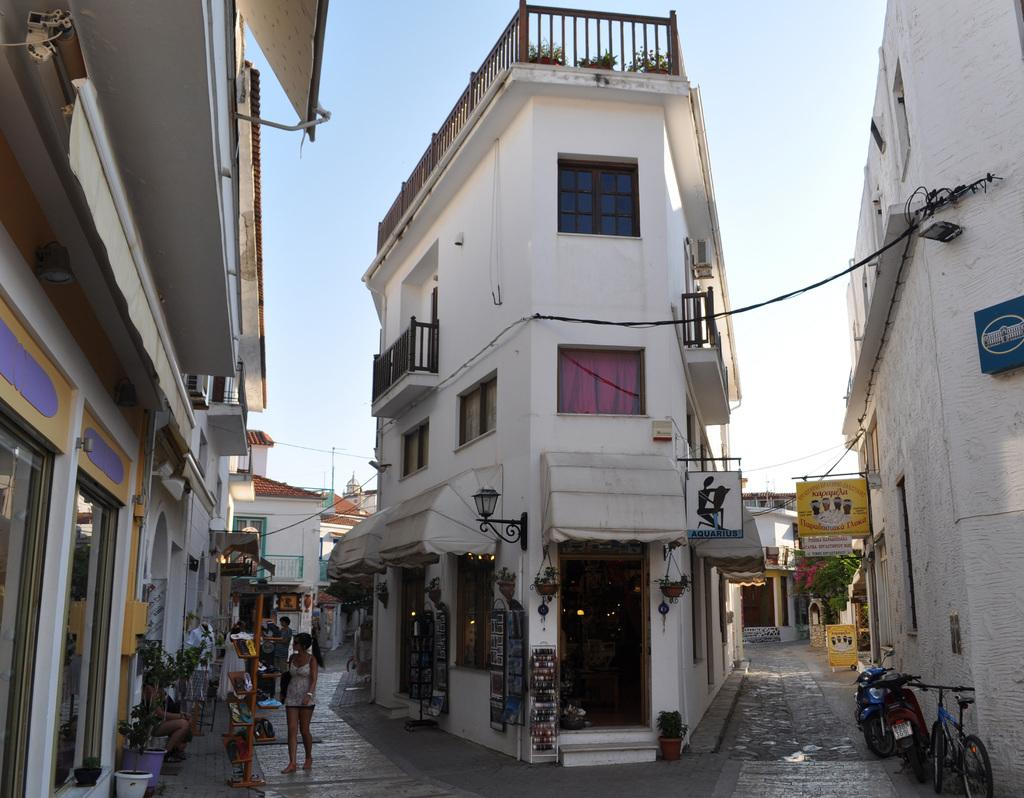How many people are in the group visible in the image? There is a group of people in the image, but the exact number cannot be determined from the provided facts. What type of structures can be seen in the image? There are buildings in the image. What mode of transportation is visible in the image? A bicycle is visible in the image, and motorcycles are present on the road in the image. What can be found in the background of the image? There are notice boards and cables visible in the background of the image. What type of apparel is the lock wearing in the image? There is no lock or apparel present in the image. What type of hall can be seen in the background of the image? There is no hall visible in the background of the image. 